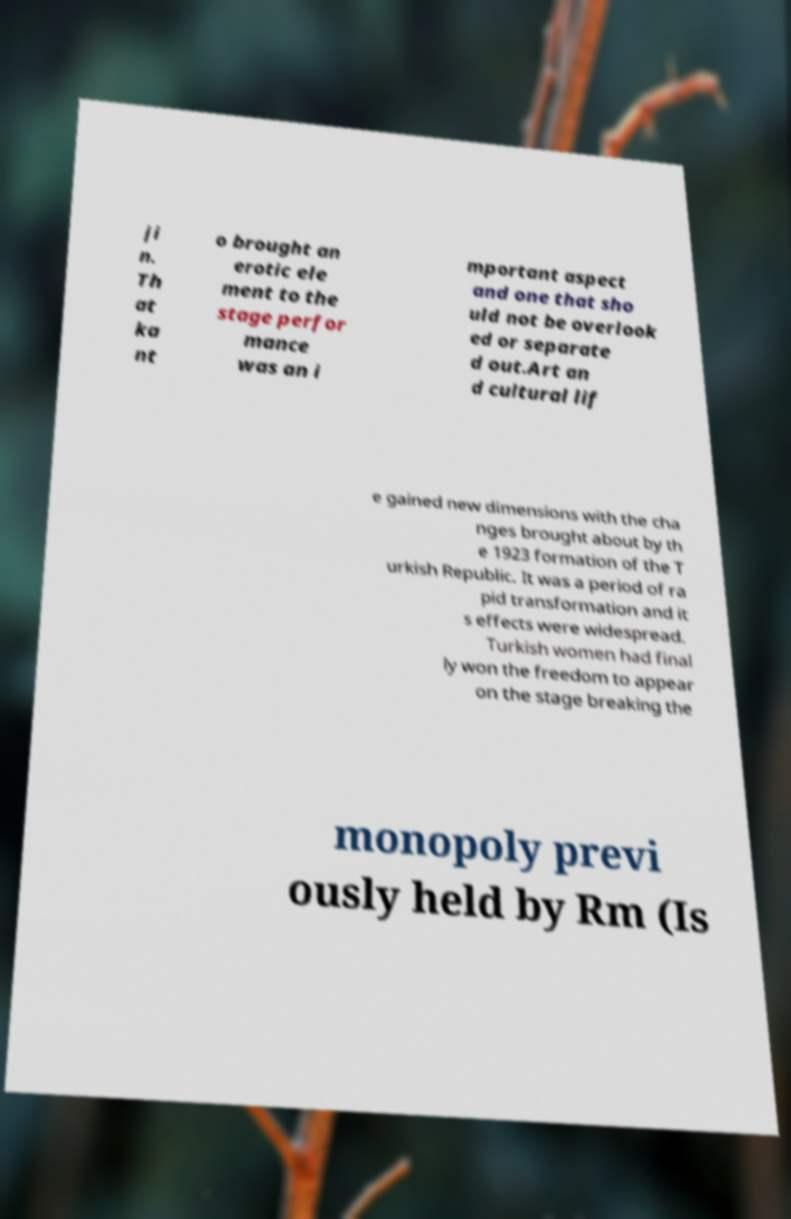Can you accurately transcribe the text from the provided image for me? ji n. Th at ka nt o brought an erotic ele ment to the stage perfor mance was an i mportant aspect and one that sho uld not be overlook ed or separate d out.Art an d cultural lif e gained new dimensions with the cha nges brought about by th e 1923 formation of the T urkish Republic. It was a period of ra pid transformation and it s effects were widespread. Turkish women had final ly won the freedom to appear on the stage breaking the monopoly previ ously held by Rm (Is 